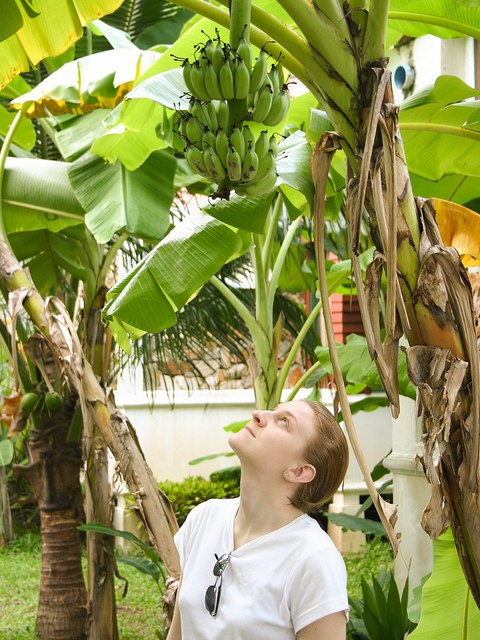Describe the objects in this image and their specific colors. I can see people in darkgreen, lightgray, and tan tones and banana in darkgreen, olive, and black tones in this image. 